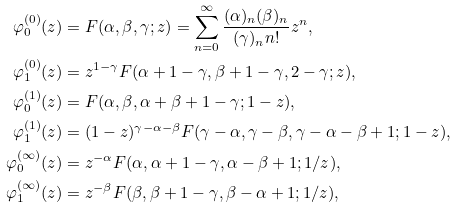<formula> <loc_0><loc_0><loc_500><loc_500>\varphi ^ { ( 0 ) } _ { 0 } ( z ) & = F ( \alpha , \beta , \gamma ; z ) = \sum _ { n = 0 } ^ { \infty } \frac { ( \alpha ) _ { n } ( \beta ) _ { n } } { ( \gamma ) _ { n } n ! } z ^ { n } , \\ \varphi ^ { ( 0 ) } _ { 1 } ( z ) & = z ^ { 1 - \gamma } F ( \alpha + 1 - \gamma , \beta + 1 - \gamma , 2 - \gamma ; z ) , \\ \varphi ^ { ( 1 ) } _ { 0 } ( z ) & = F ( \alpha , \beta , \alpha + \beta + 1 - \gamma ; 1 - z ) , \\ \varphi ^ { ( 1 ) } _ { 1 } ( z ) & = ( 1 - z ) ^ { \gamma - \alpha - \beta } F ( \gamma - \alpha , \gamma - \beta , \gamma - \alpha - \beta + 1 ; 1 - z ) , \\ \varphi ^ { ( \infty ) } _ { 0 } ( z ) & = z ^ { - \alpha } F ( \alpha , \alpha + 1 - \gamma , \alpha - \beta + 1 ; 1 / z ) , \\ \varphi ^ { ( \infty ) } _ { 1 } ( z ) & = z ^ { - \beta } F ( \beta , \beta + 1 - \gamma , \beta - \alpha + 1 ; 1 / z ) ,</formula> 